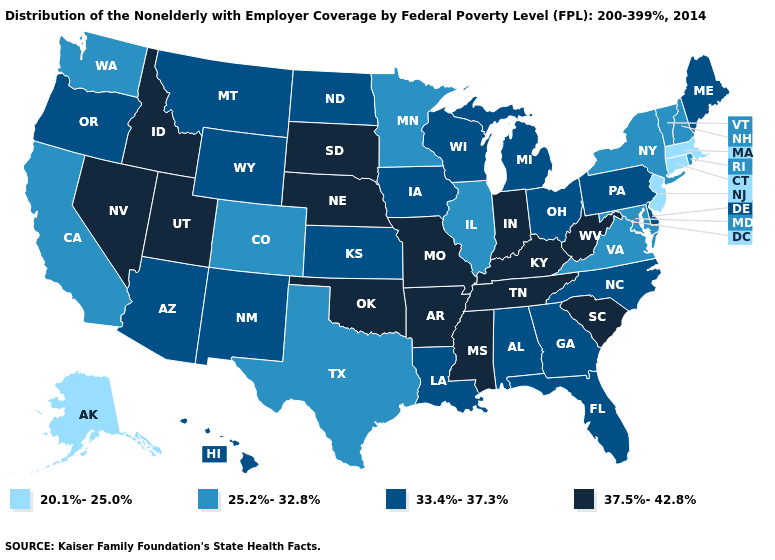What is the value of Idaho?
Give a very brief answer. 37.5%-42.8%. Among the states that border West Virginia , which have the highest value?
Quick response, please. Kentucky. Name the states that have a value in the range 37.5%-42.8%?
Answer briefly. Arkansas, Idaho, Indiana, Kentucky, Mississippi, Missouri, Nebraska, Nevada, Oklahoma, South Carolina, South Dakota, Tennessee, Utah, West Virginia. What is the lowest value in the USA?
Quick response, please. 20.1%-25.0%. What is the lowest value in states that border New York?
Keep it brief. 20.1%-25.0%. Name the states that have a value in the range 37.5%-42.8%?
Concise answer only. Arkansas, Idaho, Indiana, Kentucky, Mississippi, Missouri, Nebraska, Nevada, Oklahoma, South Carolina, South Dakota, Tennessee, Utah, West Virginia. What is the value of Tennessee?
Write a very short answer. 37.5%-42.8%. What is the highest value in states that border Georgia?
Quick response, please. 37.5%-42.8%. Which states hav the highest value in the West?
Answer briefly. Idaho, Nevada, Utah. What is the highest value in states that border North Dakota?
Answer briefly. 37.5%-42.8%. Among the states that border Missouri , which have the highest value?
Quick response, please. Arkansas, Kentucky, Nebraska, Oklahoma, Tennessee. Name the states that have a value in the range 25.2%-32.8%?
Keep it brief. California, Colorado, Illinois, Maryland, Minnesota, New Hampshire, New York, Rhode Island, Texas, Vermont, Virginia, Washington. Among the states that border Michigan , which have the lowest value?
Quick response, please. Ohio, Wisconsin. Name the states that have a value in the range 33.4%-37.3%?
Give a very brief answer. Alabama, Arizona, Delaware, Florida, Georgia, Hawaii, Iowa, Kansas, Louisiana, Maine, Michigan, Montana, New Mexico, North Carolina, North Dakota, Ohio, Oregon, Pennsylvania, Wisconsin, Wyoming. What is the highest value in states that border Maryland?
Quick response, please. 37.5%-42.8%. 